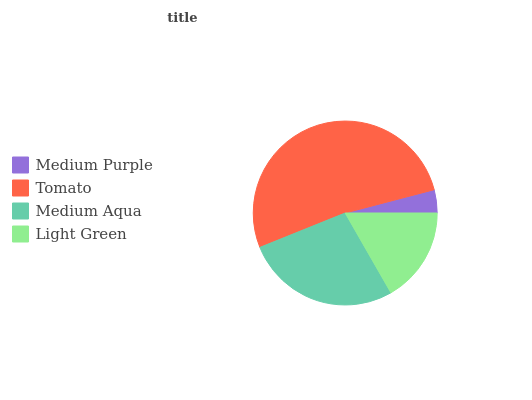Is Medium Purple the minimum?
Answer yes or no. Yes. Is Tomato the maximum?
Answer yes or no. Yes. Is Medium Aqua the minimum?
Answer yes or no. No. Is Medium Aqua the maximum?
Answer yes or no. No. Is Tomato greater than Medium Aqua?
Answer yes or no. Yes. Is Medium Aqua less than Tomato?
Answer yes or no. Yes. Is Medium Aqua greater than Tomato?
Answer yes or no. No. Is Tomato less than Medium Aqua?
Answer yes or no. No. Is Medium Aqua the high median?
Answer yes or no. Yes. Is Light Green the low median?
Answer yes or no. Yes. Is Light Green the high median?
Answer yes or no. No. Is Tomato the low median?
Answer yes or no. No. 